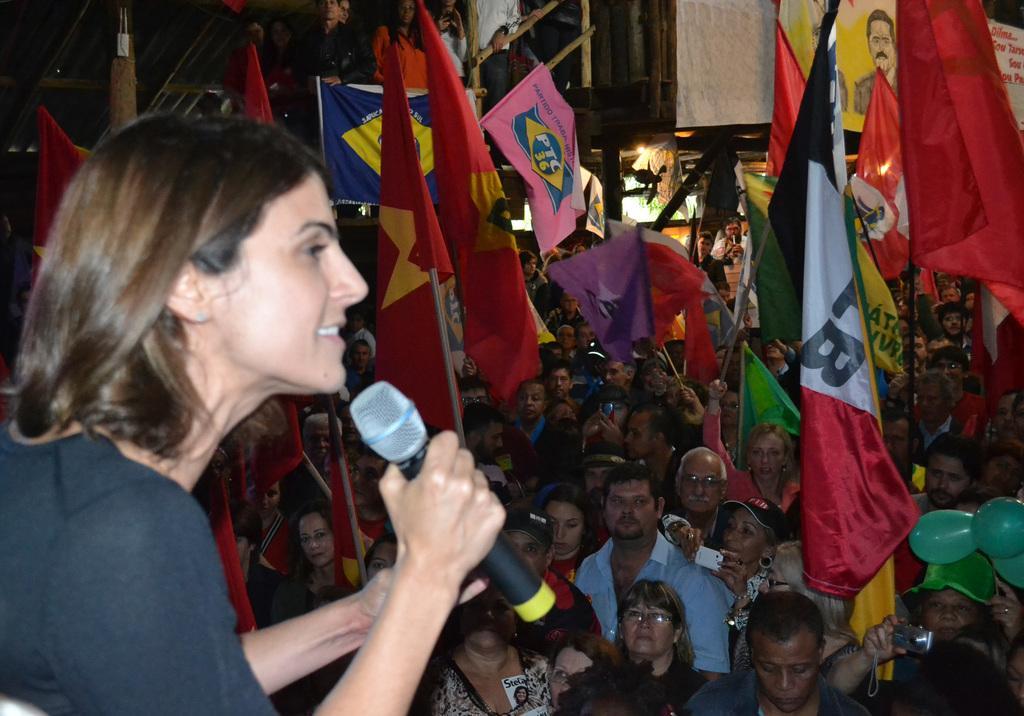Can you describe this image briefly? In this image there are many people standing. They are holding flags in their hands. To the left there is a woman holding a microphone. At the top there is a railing. 